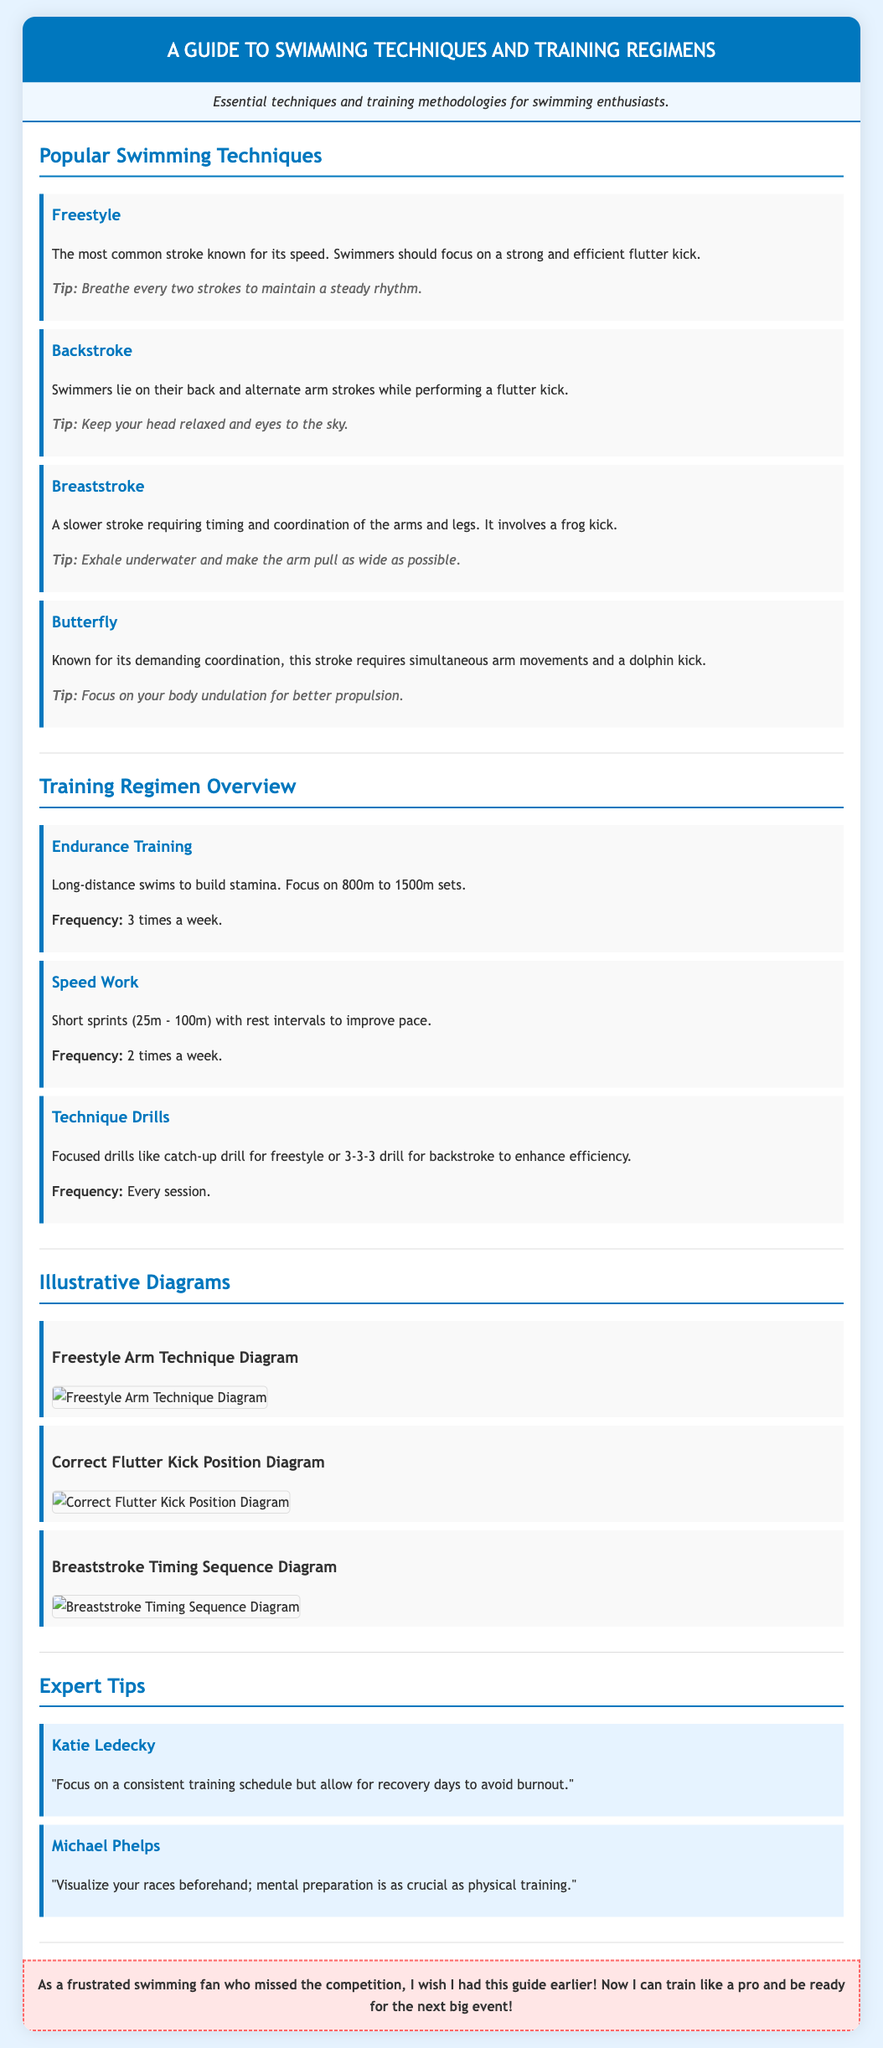What are the popular swimming techniques mentioned? The document lists several techniques, including Freestyle, Backstroke, Breaststroke, and Butterfly.
Answer: Freestyle, Backstroke, Breaststroke, Butterfly How often should endurance training be done? The section on training regimens states that endurance training should be done three times a week.
Answer: 3 times a week What type of kick is used in Breaststroke? The Breaststroke technique specifically mentions using a frog kick.
Answer: Frog kick Who is quoted in the expert tips section? The expert tips section includes quotes from Katie Ledecky and Michael Phelps.
Answer: Katie Ledecky, Michael Phelps What focus is recommended for freestyle breathing? The Freestyle technique emphasizes breathing every two strokes to maintain rhythm.
Answer: Every two strokes What is the focus of Speed Work training? The Speed Work regimen emphasizes short sprints with rest intervals to improve pace.
Answer: Short sprints Which diagram shows the arm technique for Freestyle? The document has a specific diagram titled "Freestyle Arm Technique Diagram."
Answer: Freestyle Arm Technique Diagram What is the main purpose of the described techniques? The techniques are aimed at improving swimming speed and efficiency.
Answer: Improve speed and efficiency 